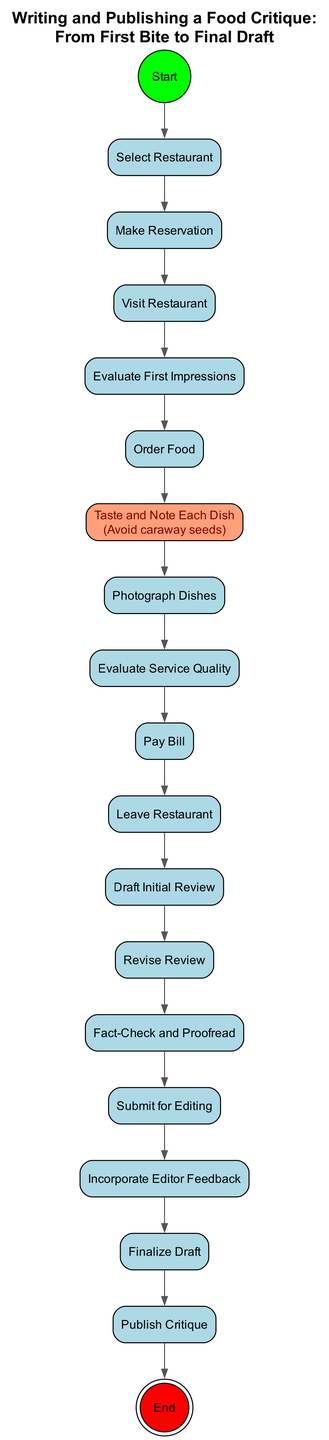What is the first action in the diagram? The diagram shows that the first action is "Select Restaurant," which is connected directly to the Start node as the initial step in the process.
Answer: Select Restaurant How many action nodes are present in the diagram? By counting all the action nodes listed in the diagram, we find that there are 13 action nodes total, each representing a specific step in the process of writing and publishing a food critique.
Answer: 13 What action follows "Taste and Note Each Dish"? The flow of the diagram indicates that after "Taste and Note Each Dish," the next action is "Photograph Dishes," meaning this activity comes right after tasting the dishes.
Answer: Photograph Dishes What is the final action in the process? The last action indicated in the diagram is "Publish Critique," which comes just before reaching the final node labeled "End." This shows that publishing is the concluding step of the critique process.
Answer: Publish Critique Identify the action node that includes a guard condition. The action node "Taste and Note Each Dish" contains a guard condition that specifies to "Avoid caraway seeds," indicating a special requirement for this step in the critique process.
Answer: Taste and Note Each Dish What must be done after "Draft Initial Review"? Upon examining the actions that follow "Draft Initial Review," we see that the next step in the process is "Revise Review," which involves improving the initial draft before further steps.
Answer: Revise Review What is the relationship between "Make Reservation" and "Visit Restaurant"? The flow shows that "Make Reservation" leads directly to "Visit Restaurant," meaning that a reservation must be made first in order to visit the selected restaurant as the next step.
Answer: Direct connection How many connections (edges) are there in total? By analyzing the flow and counting the connections between all action nodes, we determine that there are 14 edges that connect the action nodes, including the initial and final nodes.
Answer: 14 